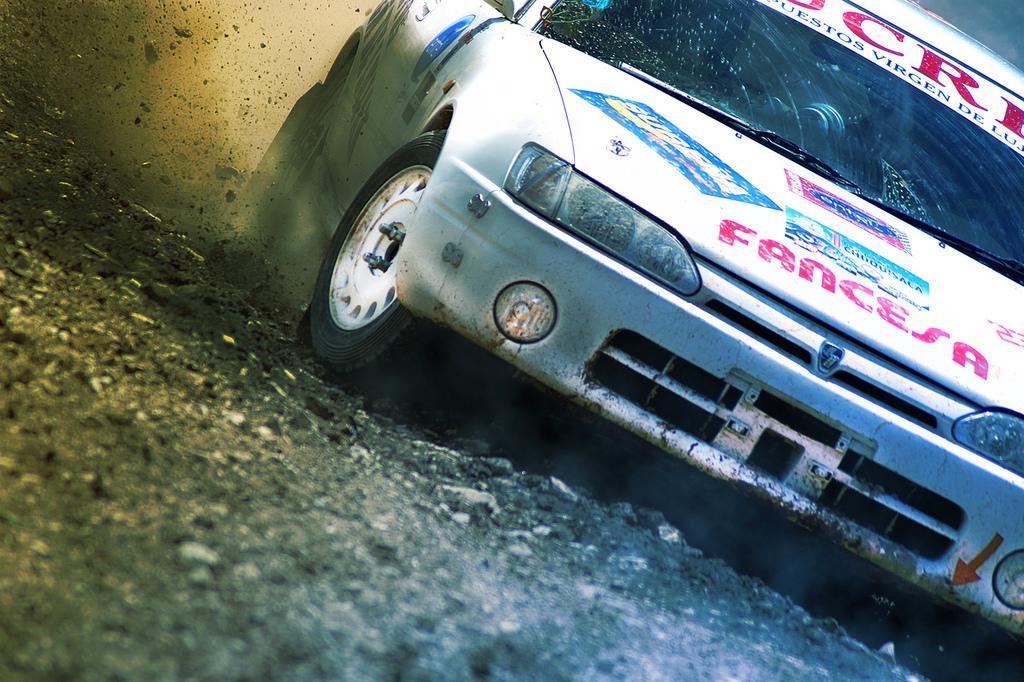Describe this image in one or two sentences. This image consists of a car in white color on which there is a text. At the bottom, there is a ground. On the left, we can see the dust in the air. 